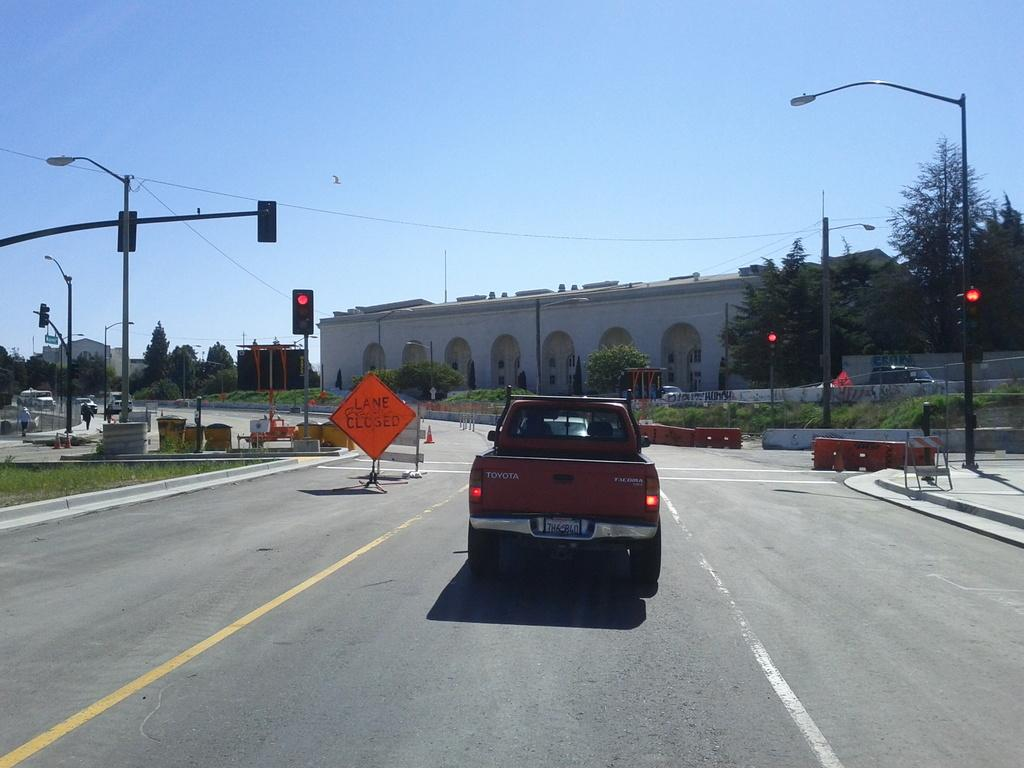What can be seen on the road in the image? There are vehicles on the road in the image. What is visible in the background of the image? In the background of the image, there are sign boards, traffic lights, poles, trees, and buildings. How many types of infrastructure can be seen in the background of the image? There are at least five types of infrastructure visible in the background: sign boards, traffic lights, poles, trees, and buildings. Can you see any squirrels climbing the trees in the image? There are no squirrels visible in the image; only vehicles, sign boards, traffic lights, poles, trees, and buildings can be seen. Are there any ants crawling on the vehicles in the image? There is no indication of ants present in the image; only vehicles, sign boards, traffic lights, poles, trees, and buildings are visible. 